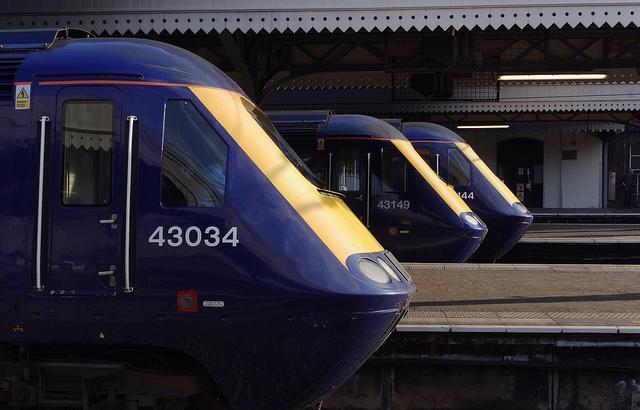How many trains are there?
Give a very brief answer. 3. How many beds are in this room?
Give a very brief answer. 0. 